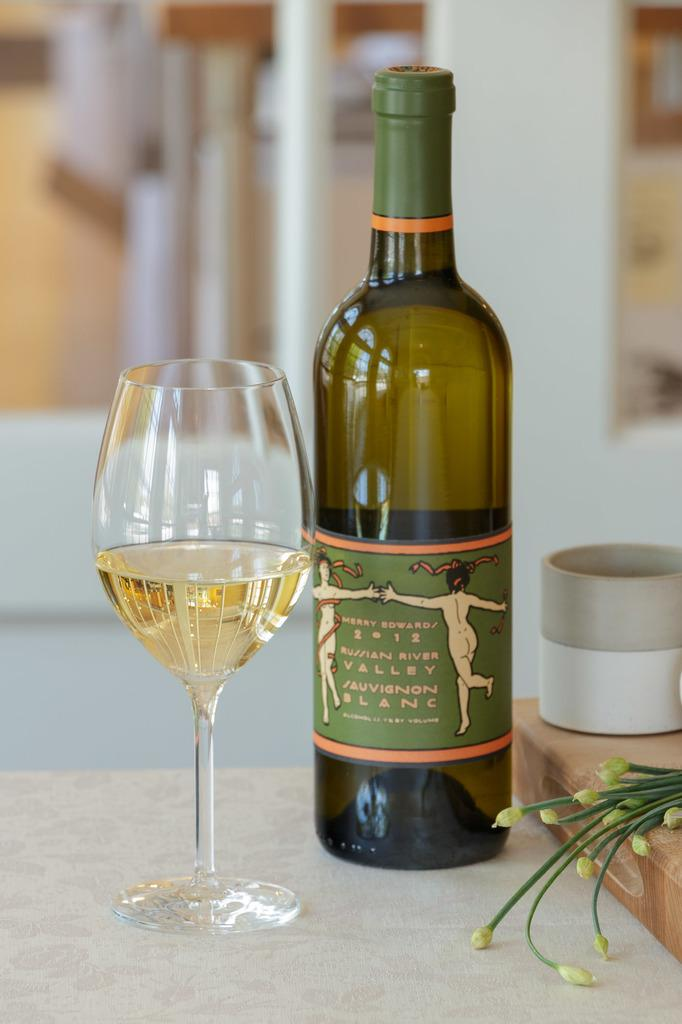<image>
Render a clear and concise summary of the photo. A bottle of Merry Edward wine next to a half filled glass. 